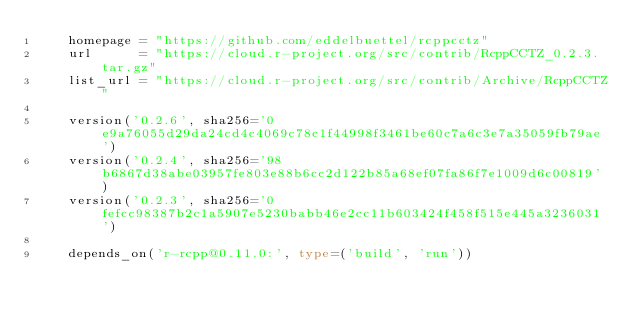Convert code to text. <code><loc_0><loc_0><loc_500><loc_500><_Python_>    homepage = "https://github.com/eddelbuettel/rcppcctz"
    url      = "https://cloud.r-project.org/src/contrib/RcppCCTZ_0.2.3.tar.gz"
    list_url = "https://cloud.r-project.org/src/contrib/Archive/RcppCCTZ"

    version('0.2.6', sha256='0e9a76055d29da24cd4c4069c78c1f44998f3461be60c7a6c3e7a35059fb79ae')
    version('0.2.4', sha256='98b6867d38abe03957fe803e88b6cc2d122b85a68ef07fa86f7e1009d6c00819')
    version('0.2.3', sha256='0fefcc98387b2c1a5907e5230babb46e2cc11b603424f458f515e445a3236031')

    depends_on('r-rcpp@0.11.0:', type=('build', 'run'))
</code> 